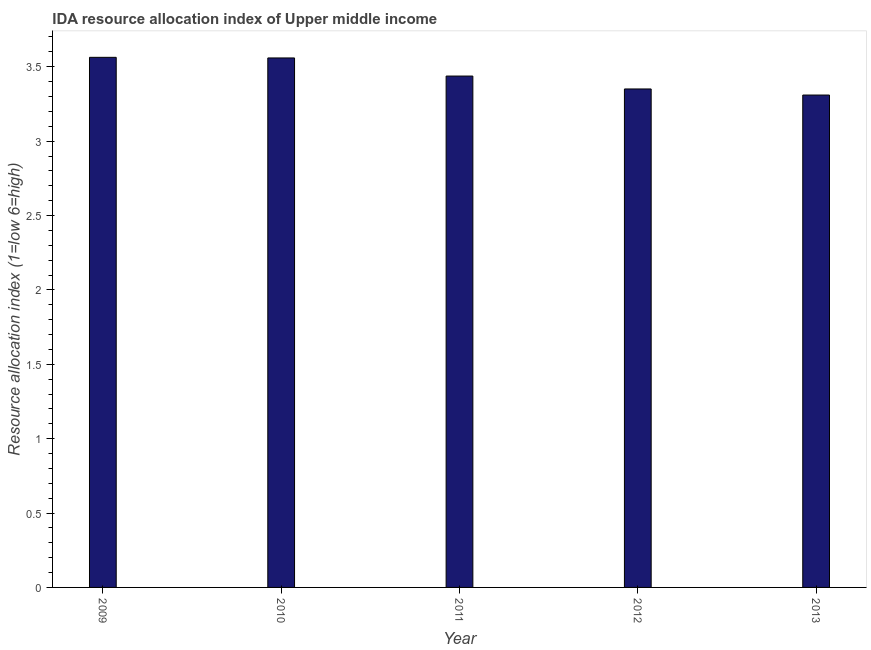Does the graph contain any zero values?
Your answer should be very brief. No. What is the title of the graph?
Keep it short and to the point. IDA resource allocation index of Upper middle income. What is the label or title of the Y-axis?
Provide a short and direct response. Resource allocation index (1=low 6=high). What is the ida resource allocation index in 2013?
Offer a very short reply. 3.31. Across all years, what is the maximum ida resource allocation index?
Ensure brevity in your answer.  3.56. Across all years, what is the minimum ida resource allocation index?
Keep it short and to the point. 3.31. What is the sum of the ida resource allocation index?
Your answer should be very brief. 17.22. What is the difference between the ida resource allocation index in 2010 and 2011?
Your answer should be very brief. 0.12. What is the average ida resource allocation index per year?
Ensure brevity in your answer.  3.44. What is the median ida resource allocation index?
Your response must be concise. 3.44. In how many years, is the ida resource allocation index greater than 0.8 ?
Ensure brevity in your answer.  5. Is the difference between the ida resource allocation index in 2011 and 2012 greater than the difference between any two years?
Keep it short and to the point. No. What is the difference between the highest and the second highest ida resource allocation index?
Provide a succinct answer. 0. What is the difference between two consecutive major ticks on the Y-axis?
Provide a succinct answer. 0.5. Are the values on the major ticks of Y-axis written in scientific E-notation?
Ensure brevity in your answer.  No. What is the Resource allocation index (1=low 6=high) of 2009?
Ensure brevity in your answer.  3.56. What is the Resource allocation index (1=low 6=high) of 2010?
Offer a terse response. 3.56. What is the Resource allocation index (1=low 6=high) in 2011?
Keep it short and to the point. 3.44. What is the Resource allocation index (1=low 6=high) in 2012?
Provide a succinct answer. 3.35. What is the Resource allocation index (1=low 6=high) in 2013?
Your response must be concise. 3.31. What is the difference between the Resource allocation index (1=low 6=high) in 2009 and 2010?
Ensure brevity in your answer.  0. What is the difference between the Resource allocation index (1=low 6=high) in 2009 and 2011?
Provide a short and direct response. 0.13. What is the difference between the Resource allocation index (1=low 6=high) in 2009 and 2012?
Offer a very short reply. 0.21. What is the difference between the Resource allocation index (1=low 6=high) in 2009 and 2013?
Your answer should be compact. 0.25. What is the difference between the Resource allocation index (1=low 6=high) in 2010 and 2011?
Provide a succinct answer. 0.12. What is the difference between the Resource allocation index (1=low 6=high) in 2010 and 2012?
Your answer should be compact. 0.21. What is the difference between the Resource allocation index (1=low 6=high) in 2010 and 2013?
Your answer should be very brief. 0.25. What is the difference between the Resource allocation index (1=low 6=high) in 2011 and 2012?
Keep it short and to the point. 0.09. What is the difference between the Resource allocation index (1=low 6=high) in 2011 and 2013?
Offer a terse response. 0.13. What is the difference between the Resource allocation index (1=low 6=high) in 2012 and 2013?
Your response must be concise. 0.04. What is the ratio of the Resource allocation index (1=low 6=high) in 2009 to that in 2012?
Give a very brief answer. 1.06. What is the ratio of the Resource allocation index (1=low 6=high) in 2009 to that in 2013?
Offer a terse response. 1.08. What is the ratio of the Resource allocation index (1=low 6=high) in 2010 to that in 2011?
Make the answer very short. 1.03. What is the ratio of the Resource allocation index (1=low 6=high) in 2010 to that in 2012?
Your answer should be compact. 1.06. What is the ratio of the Resource allocation index (1=low 6=high) in 2010 to that in 2013?
Give a very brief answer. 1.07. What is the ratio of the Resource allocation index (1=low 6=high) in 2011 to that in 2012?
Make the answer very short. 1.03. What is the ratio of the Resource allocation index (1=low 6=high) in 2011 to that in 2013?
Offer a very short reply. 1.04. What is the ratio of the Resource allocation index (1=low 6=high) in 2012 to that in 2013?
Offer a very short reply. 1.01. 